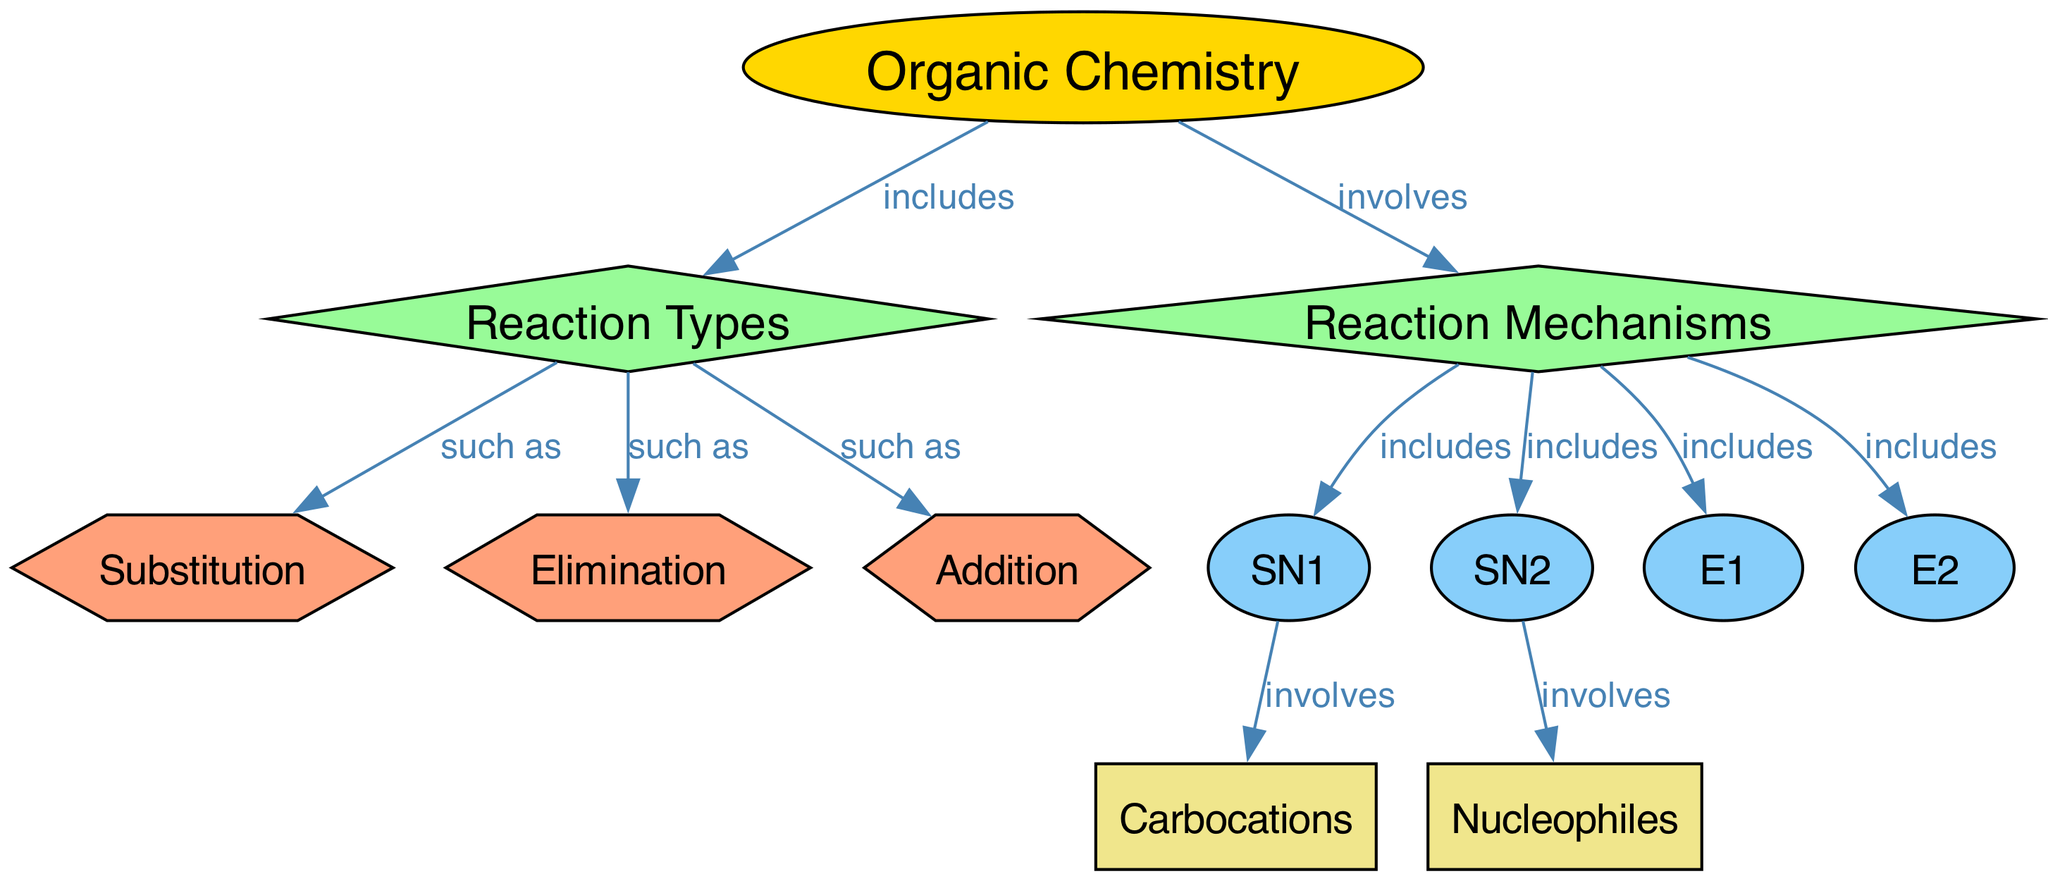What are the three main types of reactions in organic chemistry? The diagram shows the node "reaction_types," which branches out into three specific types: "substitution," "elimination," and "addition." These are explicitly labeled in the diagram, illustrating the main categories of reactions under organic chemistry.
Answer: substitution, elimination, addition How many mechanisms are included in the diagram? The "mechanisms" node connects to four individual mechanisms: "SN1," "SN2," "E1," and "E2." By counting these connections, we find that there are four mechanisms mentioned in total according to the edges leading from the "mechanisms" node.
Answer: 4 What involves carbocations as a mechanism? The diagram specifies that the "SN1" mechanism involves "carbocations," indicating a direct relationship between these two nodes. Therefore, looking at the edge pointing from "sn1" to "carbocations," it's clear that "SN1" is the mechanism associated with carbocations.
Answer: SN1 Which reaction type is associated with nucleophiles? The node "nucleophiles" is connected to the "SN2" mechanism, which indicates that nucleophiles are specifically involved in this type of reaction. The edge between "sn2" and "nucleophiles" confirms this relationship directly within the diagram.
Answer: SN2 What type of reactions does organic chemistry involve? According to the connections shown in the diagram, organic chemistry involves "reaction mechanisms" and "reaction types." The relationship is established through the edges indicating involvement and inclusion, linking "organic_chemistry" to both categories.
Answer: reaction mechanisms and reaction types Which reaction type does "E1" belong to? "E1" is categorized under the "mechanisms" node, which further details it under the broader context of reaction types in organic chemistry. The edges show that "E1" is included as one of the mechanisms, indicating it appears specifically as part of the elimination processes.
Answer: elimination 